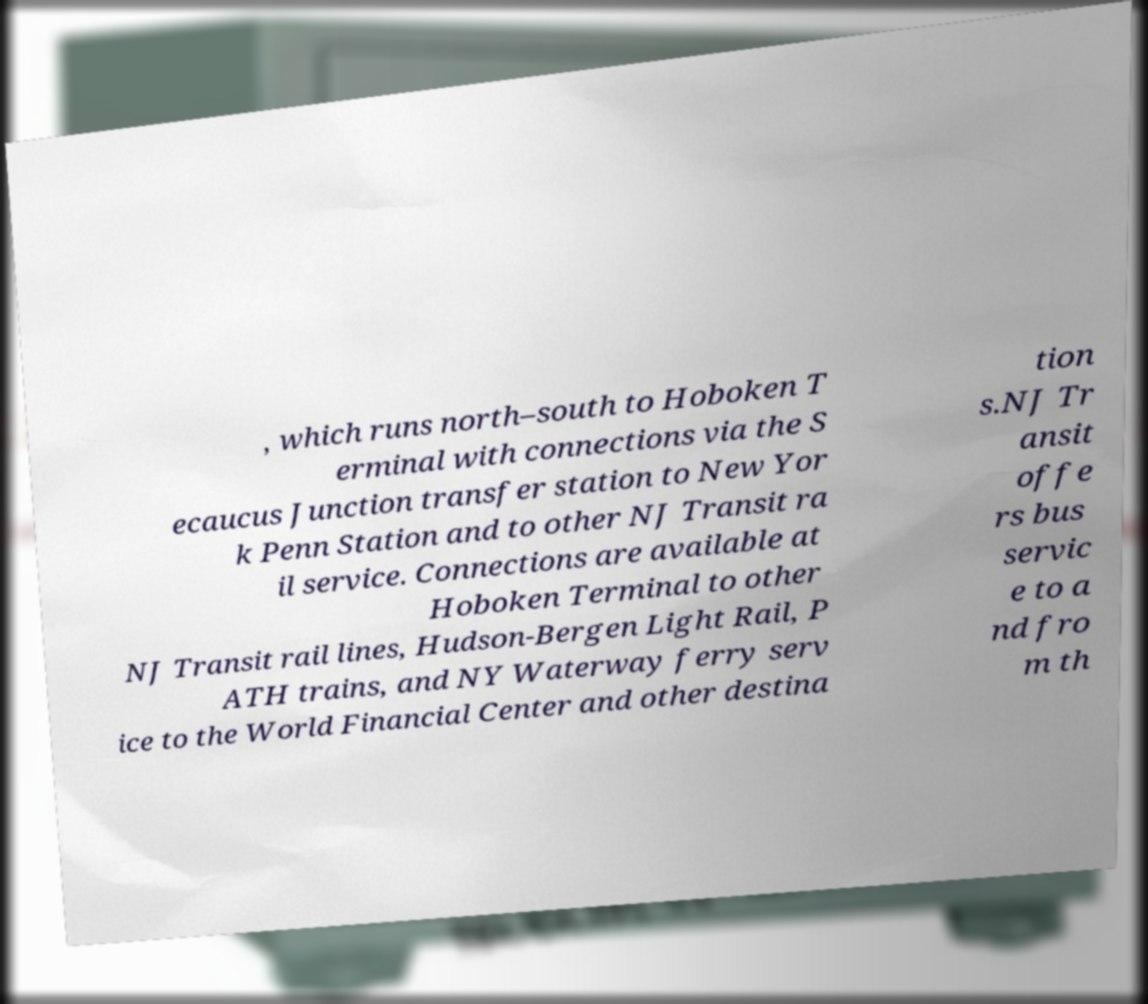Please read and relay the text visible in this image. What does it say? , which runs north–south to Hoboken T erminal with connections via the S ecaucus Junction transfer station to New Yor k Penn Station and to other NJ Transit ra il service. Connections are available at Hoboken Terminal to other NJ Transit rail lines, Hudson-Bergen Light Rail, P ATH trains, and NY Waterway ferry serv ice to the World Financial Center and other destina tion s.NJ Tr ansit offe rs bus servic e to a nd fro m th 